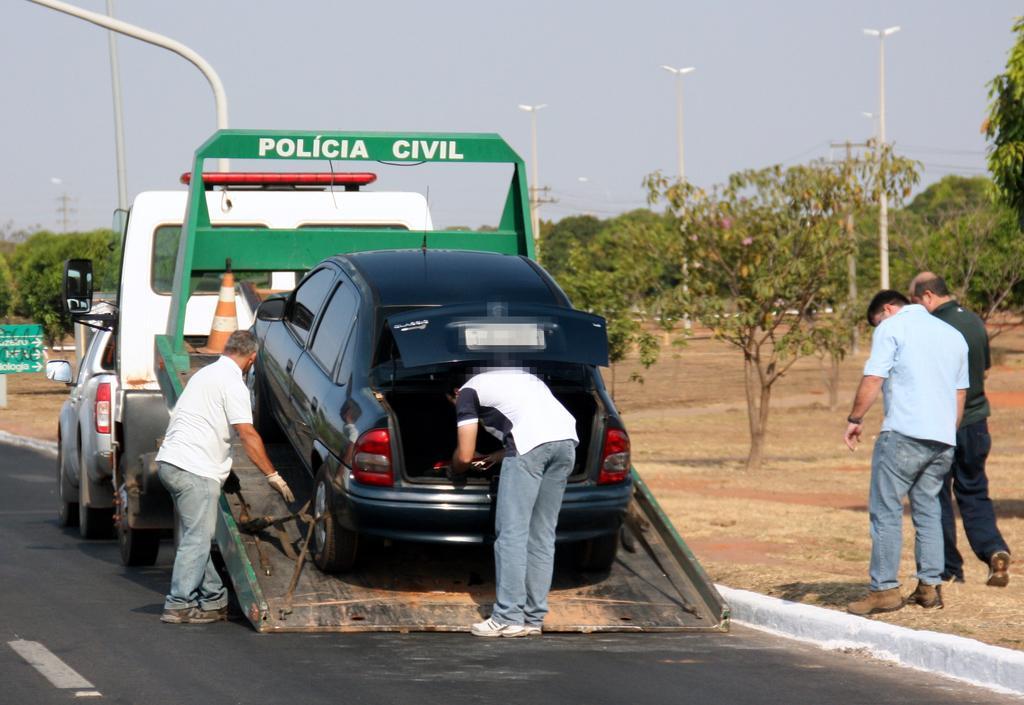Describe this image in one or two sentences. In this picture we can observe a vehicle. There is a black color car on this vehicle. We can observe a road. There are some people standing on the land. In the background we can observe trees, poles and a sky. 